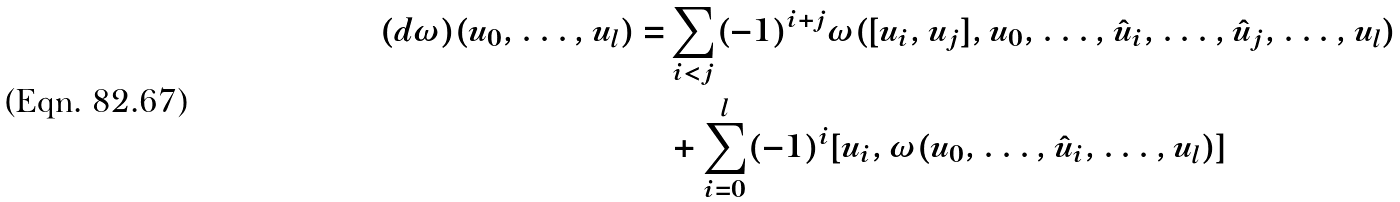<formula> <loc_0><loc_0><loc_500><loc_500>( d \omega ) ( u _ { 0 } , \dots , u _ { l } ) = & \sum _ { i < j } ( - 1 ) ^ { i + j } \omega ( [ u _ { i } , u _ { j } ] , u _ { 0 } , \dots , \hat { u } _ { i } , \dots , \hat { u } _ { j } , \dots , u _ { l } ) \\ & + \sum _ { i = 0 } ^ { l } ( - 1 ) ^ { i } [ u _ { i } , \omega ( u _ { 0 } , \dots , \hat { u } _ { i } , \dots , u _ { l } ) ]</formula> 